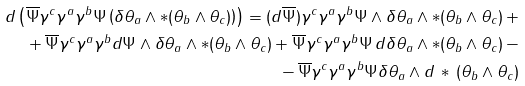Convert formula to latex. <formula><loc_0><loc_0><loc_500><loc_500>d \left ( \overline { \Psi } \gamma ^ { c } \gamma ^ { a } \gamma ^ { b } \Psi \left ( \delta \theta _ { a } \wedge * ( \theta _ { b } \wedge \theta _ { c } ) \right ) \right ) = ( d \overline { \Psi } ) \gamma ^ { c } \gamma ^ { a } \gamma ^ { b } \Psi \wedge \delta \theta _ { a } \wedge * ( \theta _ { b } \wedge \theta _ { c } ) \, + \\ + \, \overline { \Psi } \gamma ^ { c } \gamma ^ { a } \gamma ^ { b } d \Psi \wedge \delta \theta _ { a } \wedge * ( \theta _ { b } \wedge \theta _ { c } ) + \overline { \Psi } \gamma ^ { c } \gamma ^ { a } \gamma ^ { b } \Psi \, d \delta \theta _ { a } \wedge * ( \theta _ { b } \wedge \theta _ { c } ) \, - \\ - \, \overline { \Psi } \gamma ^ { c } \gamma ^ { a } \gamma ^ { b } \Psi \delta \theta _ { a } \wedge d \, * \, ( \theta _ { b } \wedge \theta _ { c } )</formula> 